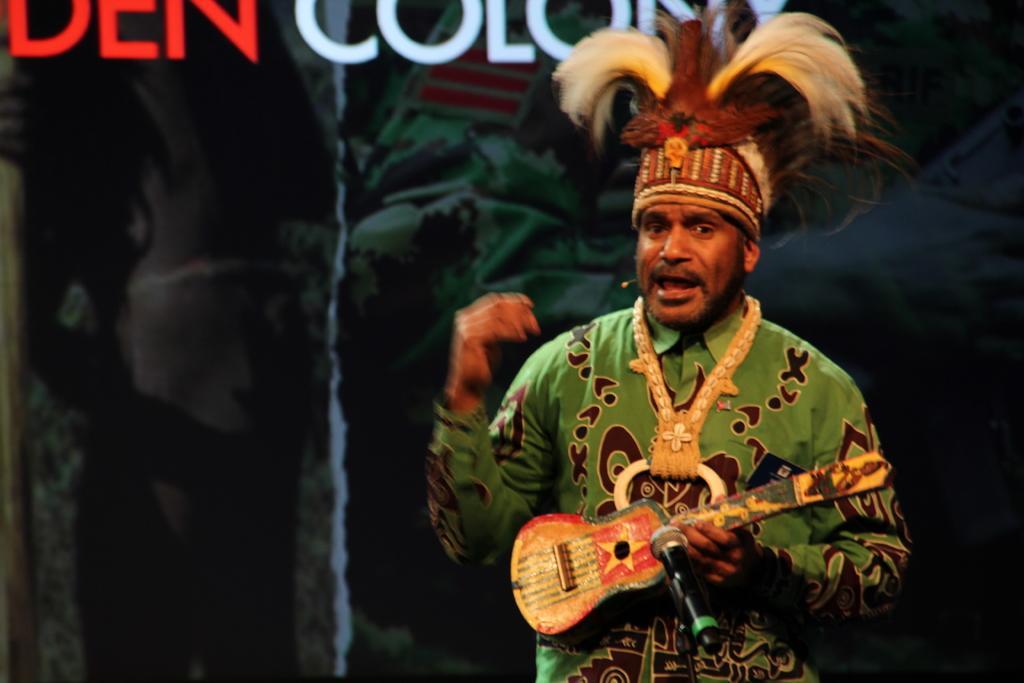Please provide a concise description of this image. There is a person standing and wearing a different costume. He is holding a guitar in front there is a mic. 